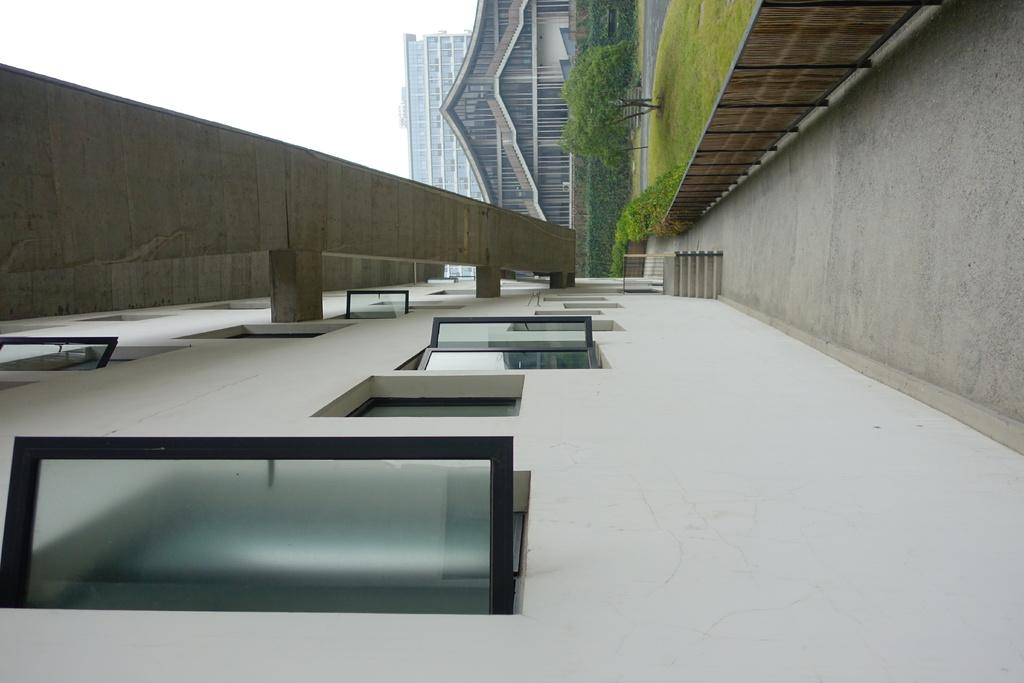What type of structures can be seen in the image? There are buildings in the image. What other natural elements are present in the image? There are trees in the image. What can be seen at the bottom of the image? The ground is visible at the bottom of the image. What type of pie is being served on the table in the image? There is no table or pie present in the image; it only features buildings, trees, and the ground. 